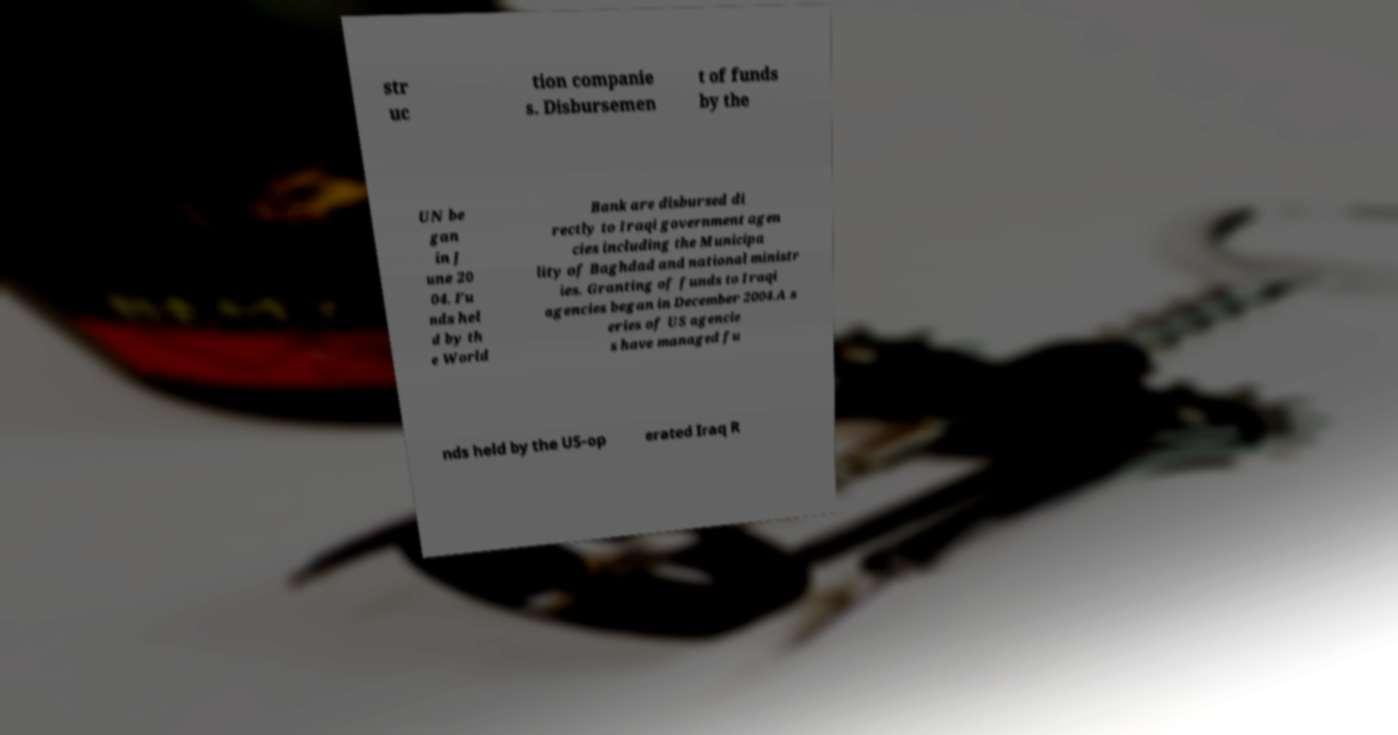Can you accurately transcribe the text from the provided image for me? str uc tion companie s. Disbursemen t of funds by the UN be gan in J une 20 04. Fu nds hel d by th e World Bank are disbursed di rectly to Iraqi government agen cies including the Municipa lity of Baghdad and national ministr ies. Granting of funds to Iraqi agencies began in December 2004.A s eries of US agencie s have managed fu nds held by the US-op erated Iraq R 